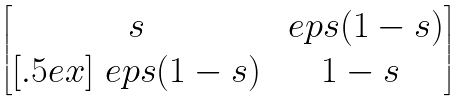<formula> <loc_0><loc_0><loc_500><loc_500>\begin{bmatrix} s & { \ e p s } ( 1 - s ) \\ [ . 5 e x ] { \ e p s } ( 1 - s ) & 1 - s \end{bmatrix}</formula> 